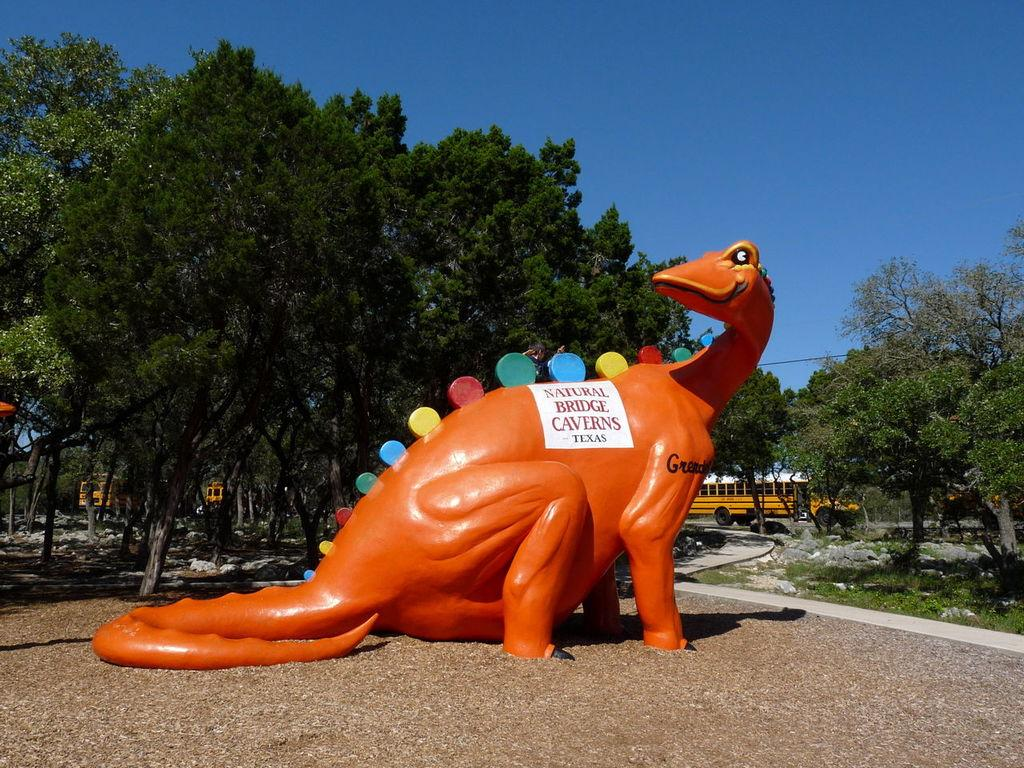What is the main subject of the image? There is a dinosaur sculpture in the image. Can you describe the color of the dinosaur sculpture? The dinosaur sculpture is orange in color. What type of natural elements can be seen in the image? There are trees and rocks in the image. What is visible on the road in the image? There is a bus on the road in the image. What part of the natural environment is visible in the image? The sky is visible in the image. What type of wave can be seen crashing on the shore in the image? There is no wave or shore present in the image; it features a dinosaur sculpture, trees, rocks, a bus, and the sky. 